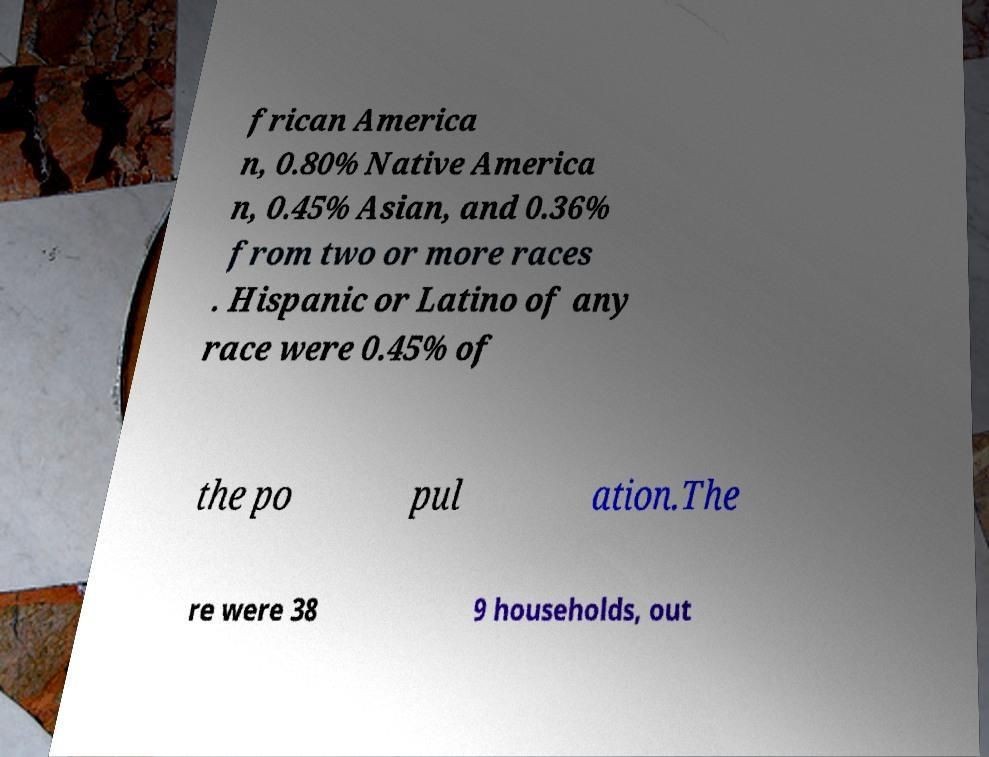There's text embedded in this image that I need extracted. Can you transcribe it verbatim? frican America n, 0.80% Native America n, 0.45% Asian, and 0.36% from two or more races . Hispanic or Latino of any race were 0.45% of the po pul ation.The re were 38 9 households, out 